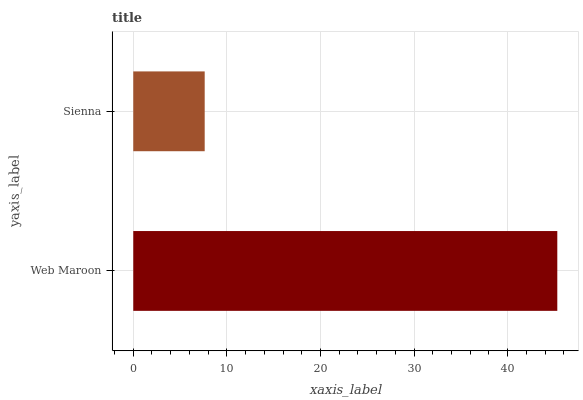Is Sienna the minimum?
Answer yes or no. Yes. Is Web Maroon the maximum?
Answer yes or no. Yes. Is Sienna the maximum?
Answer yes or no. No. Is Web Maroon greater than Sienna?
Answer yes or no. Yes. Is Sienna less than Web Maroon?
Answer yes or no. Yes. Is Sienna greater than Web Maroon?
Answer yes or no. No. Is Web Maroon less than Sienna?
Answer yes or no. No. Is Web Maroon the high median?
Answer yes or no. Yes. Is Sienna the low median?
Answer yes or no. Yes. Is Sienna the high median?
Answer yes or no. No. Is Web Maroon the low median?
Answer yes or no. No. 